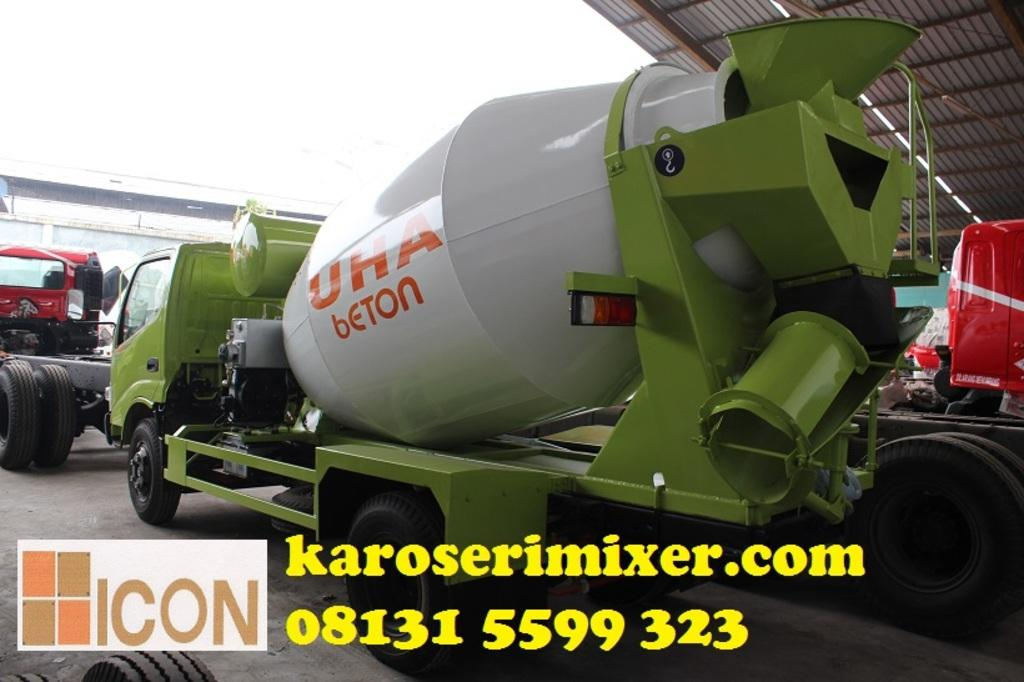What can be seen in the image? There are vehicles in the image. Can you describe one of the vehicles in more detail? One of the vehicles is white and green in color. What is visible in the background of the image? There is a shed in the background of the image. How would you describe the color of the sky in the image? The sky is white in color. Can you tell me how many pipes are visible in the image? There are no pipes present in the image. What type of parent is shown interacting with the vehicles in the image? There are no parents or interactions with vehicles depicted in the image. 